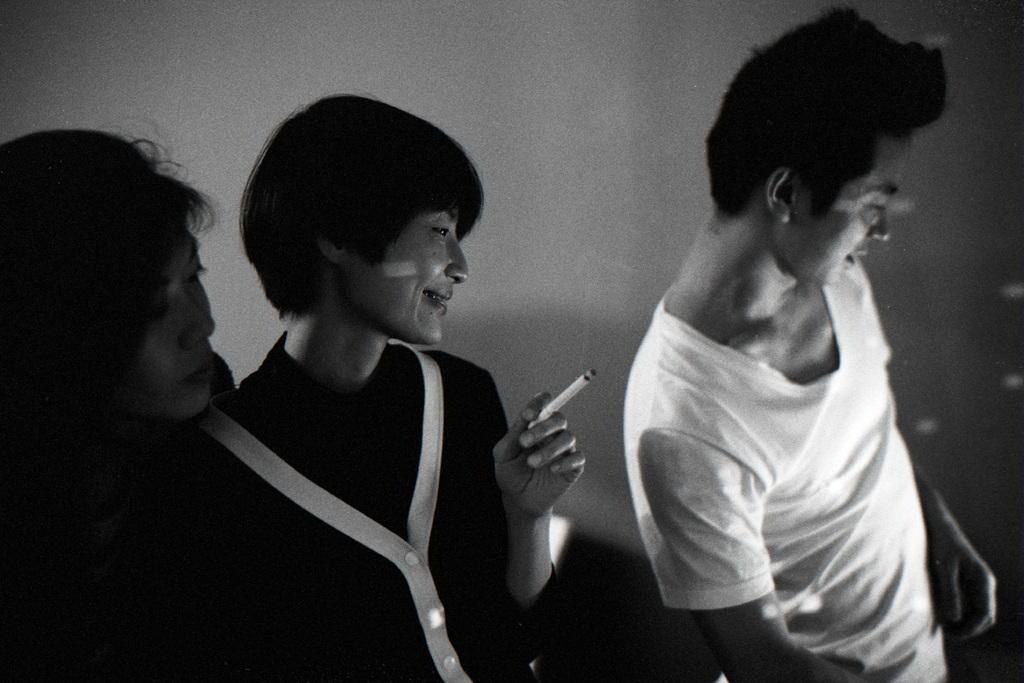In one or two sentences, can you explain what this image depicts? In this image I can see on the right side a man is there, he wore white color t-shirt. In the middle another person is holding the cigarette in the hands. On the left side there is a woman looking at that side this image is in black and white color. 